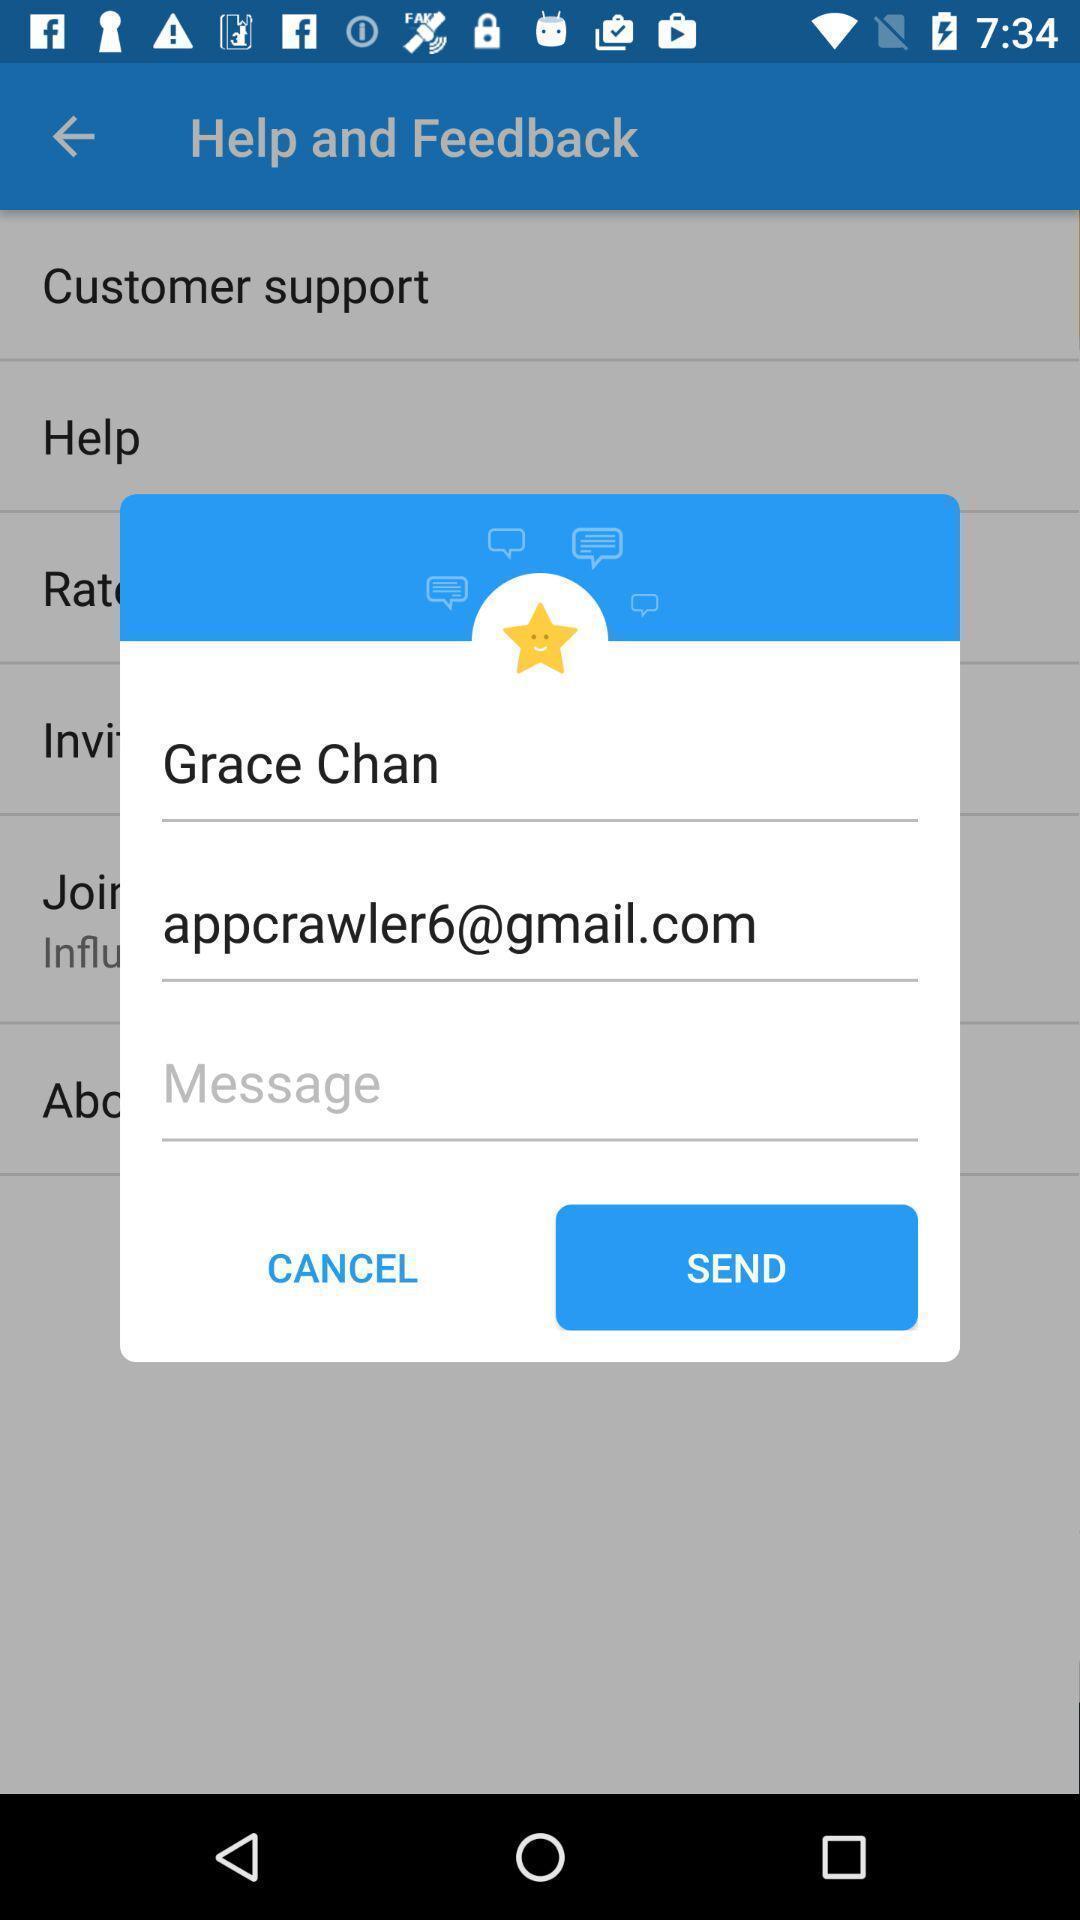Explain the elements present in this screenshot. Pop-up showing to send feedback. 